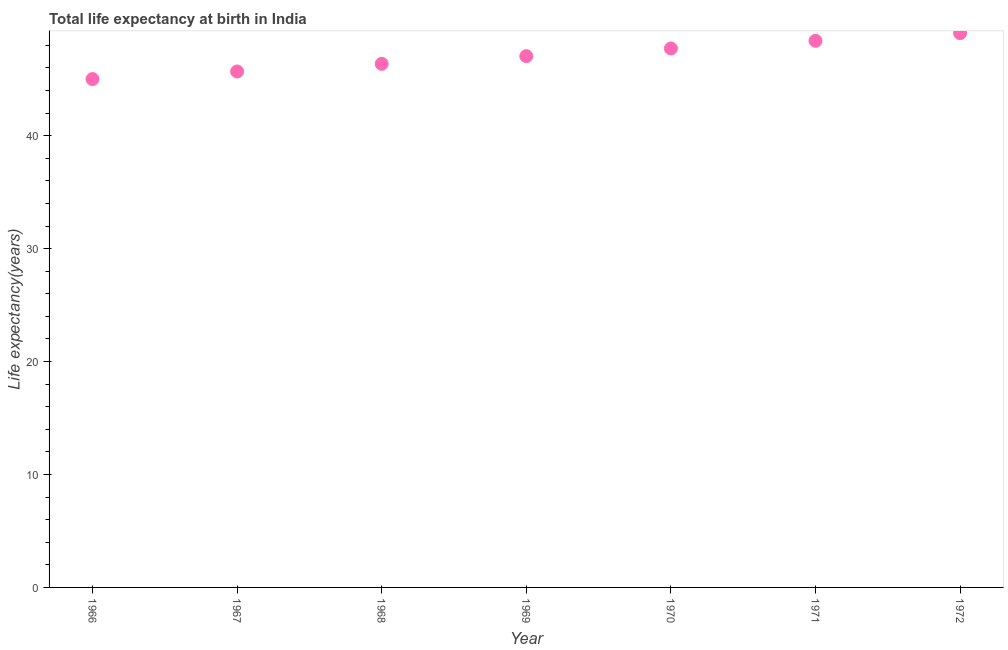What is the life expectancy at birth in 1970?
Provide a short and direct response. 47.73. Across all years, what is the maximum life expectancy at birth?
Your answer should be compact. 49.09. Across all years, what is the minimum life expectancy at birth?
Offer a terse response. 45.02. In which year was the life expectancy at birth minimum?
Make the answer very short. 1966. What is the sum of the life expectancy at birth?
Your response must be concise. 329.35. What is the difference between the life expectancy at birth in 1969 and 1971?
Provide a succinct answer. -1.36. What is the average life expectancy at birth per year?
Offer a very short reply. 47.05. What is the median life expectancy at birth?
Give a very brief answer. 47.05. In how many years, is the life expectancy at birth greater than 36 years?
Your answer should be very brief. 7. What is the ratio of the life expectancy at birth in 1967 to that in 1972?
Your answer should be very brief. 0.93. Is the difference between the life expectancy at birth in 1969 and 1970 greater than the difference between any two years?
Make the answer very short. No. What is the difference between the highest and the second highest life expectancy at birth?
Keep it short and to the point. 0.68. What is the difference between the highest and the lowest life expectancy at birth?
Make the answer very short. 4.07. Does the life expectancy at birth monotonically increase over the years?
Provide a short and direct response. Yes. How many years are there in the graph?
Offer a very short reply. 7. What is the difference between two consecutive major ticks on the Y-axis?
Provide a short and direct response. 10. What is the title of the graph?
Ensure brevity in your answer.  Total life expectancy at birth in India. What is the label or title of the X-axis?
Your answer should be very brief. Year. What is the label or title of the Y-axis?
Make the answer very short. Life expectancy(years). What is the Life expectancy(years) in 1966?
Ensure brevity in your answer.  45.02. What is the Life expectancy(years) in 1967?
Your answer should be compact. 45.69. What is the Life expectancy(years) in 1968?
Make the answer very short. 46.37. What is the Life expectancy(years) in 1969?
Make the answer very short. 47.05. What is the Life expectancy(years) in 1970?
Your response must be concise. 47.73. What is the Life expectancy(years) in 1971?
Offer a very short reply. 48.41. What is the Life expectancy(years) in 1972?
Provide a succinct answer. 49.09. What is the difference between the Life expectancy(years) in 1966 and 1967?
Your answer should be compact. -0.67. What is the difference between the Life expectancy(years) in 1966 and 1968?
Your response must be concise. -1.35. What is the difference between the Life expectancy(years) in 1966 and 1969?
Provide a succinct answer. -2.03. What is the difference between the Life expectancy(years) in 1966 and 1970?
Ensure brevity in your answer.  -2.71. What is the difference between the Life expectancy(years) in 1966 and 1971?
Keep it short and to the point. -3.39. What is the difference between the Life expectancy(years) in 1966 and 1972?
Offer a terse response. -4.07. What is the difference between the Life expectancy(years) in 1967 and 1968?
Provide a short and direct response. -0.68. What is the difference between the Life expectancy(years) in 1967 and 1969?
Your response must be concise. -1.36. What is the difference between the Life expectancy(years) in 1967 and 1970?
Your answer should be very brief. -2.04. What is the difference between the Life expectancy(years) in 1967 and 1971?
Provide a succinct answer. -2.72. What is the difference between the Life expectancy(years) in 1967 and 1972?
Your answer should be very brief. -3.4. What is the difference between the Life expectancy(years) in 1968 and 1969?
Make the answer very short. -0.68. What is the difference between the Life expectancy(years) in 1968 and 1970?
Give a very brief answer. -1.36. What is the difference between the Life expectancy(years) in 1968 and 1971?
Your answer should be very brief. -2.04. What is the difference between the Life expectancy(years) in 1968 and 1972?
Your answer should be compact. -2.72. What is the difference between the Life expectancy(years) in 1969 and 1970?
Your answer should be compact. -0.68. What is the difference between the Life expectancy(years) in 1969 and 1971?
Provide a short and direct response. -1.36. What is the difference between the Life expectancy(years) in 1969 and 1972?
Keep it short and to the point. -2.04. What is the difference between the Life expectancy(years) in 1970 and 1971?
Make the answer very short. -0.68. What is the difference between the Life expectancy(years) in 1970 and 1972?
Offer a very short reply. -1.36. What is the difference between the Life expectancy(years) in 1971 and 1972?
Your response must be concise. -0.68. What is the ratio of the Life expectancy(years) in 1966 to that in 1968?
Your answer should be compact. 0.97. What is the ratio of the Life expectancy(years) in 1966 to that in 1969?
Offer a very short reply. 0.96. What is the ratio of the Life expectancy(years) in 1966 to that in 1970?
Your answer should be very brief. 0.94. What is the ratio of the Life expectancy(years) in 1966 to that in 1971?
Keep it short and to the point. 0.93. What is the ratio of the Life expectancy(years) in 1966 to that in 1972?
Offer a very short reply. 0.92. What is the ratio of the Life expectancy(years) in 1967 to that in 1970?
Provide a short and direct response. 0.96. What is the ratio of the Life expectancy(years) in 1967 to that in 1971?
Offer a terse response. 0.94. What is the ratio of the Life expectancy(years) in 1967 to that in 1972?
Your answer should be compact. 0.93. What is the ratio of the Life expectancy(years) in 1968 to that in 1970?
Your response must be concise. 0.97. What is the ratio of the Life expectancy(years) in 1968 to that in 1971?
Make the answer very short. 0.96. What is the ratio of the Life expectancy(years) in 1968 to that in 1972?
Keep it short and to the point. 0.94. What is the ratio of the Life expectancy(years) in 1969 to that in 1971?
Your answer should be compact. 0.97. What is the ratio of the Life expectancy(years) in 1969 to that in 1972?
Provide a short and direct response. 0.96. What is the ratio of the Life expectancy(years) in 1970 to that in 1972?
Provide a short and direct response. 0.97. What is the ratio of the Life expectancy(years) in 1971 to that in 1972?
Give a very brief answer. 0.99. 